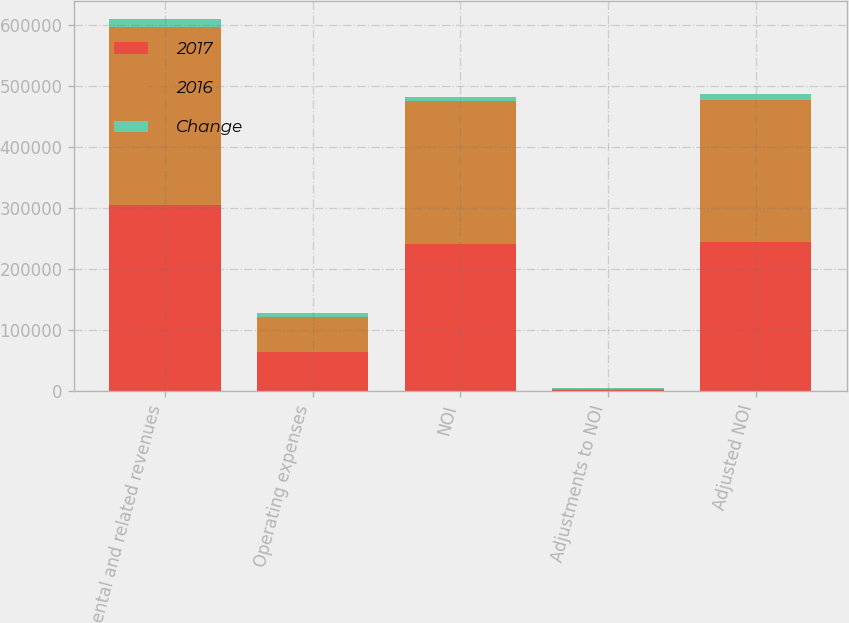<chart> <loc_0><loc_0><loc_500><loc_500><stacked_bar_chart><ecel><fcel>Rental and related revenues<fcel>Operating expenses<fcel>NOI<fcel>Adjustments to NOI<fcel>Adjusted NOI<nl><fcel>2017<fcel>304858<fcel>63612<fcel>241246<fcel>2427<fcel>243673<nl><fcel>2016<fcel>292147<fcel>58363<fcel>233784<fcel>339<fcel>234123<nl><fcel>Change<fcel>12711<fcel>5249<fcel>7462<fcel>2088<fcel>9550<nl></chart> 